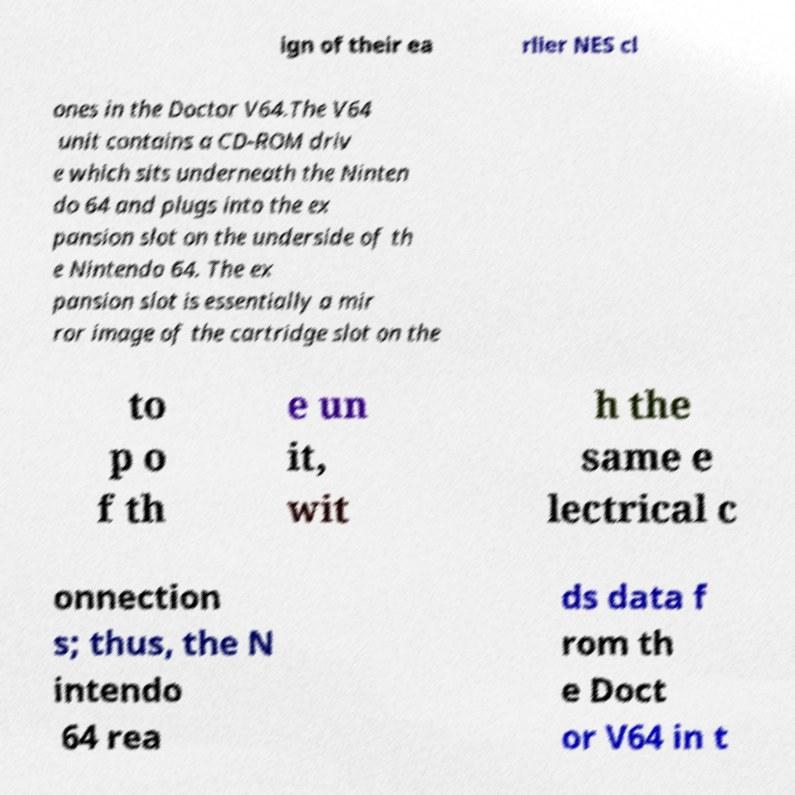What messages or text are displayed in this image? I need them in a readable, typed format. ign of their ea rlier NES cl ones in the Doctor V64.The V64 unit contains a CD-ROM driv e which sits underneath the Ninten do 64 and plugs into the ex pansion slot on the underside of th e Nintendo 64. The ex pansion slot is essentially a mir ror image of the cartridge slot on the to p o f th e un it, wit h the same e lectrical c onnection s; thus, the N intendo 64 rea ds data f rom th e Doct or V64 in t 